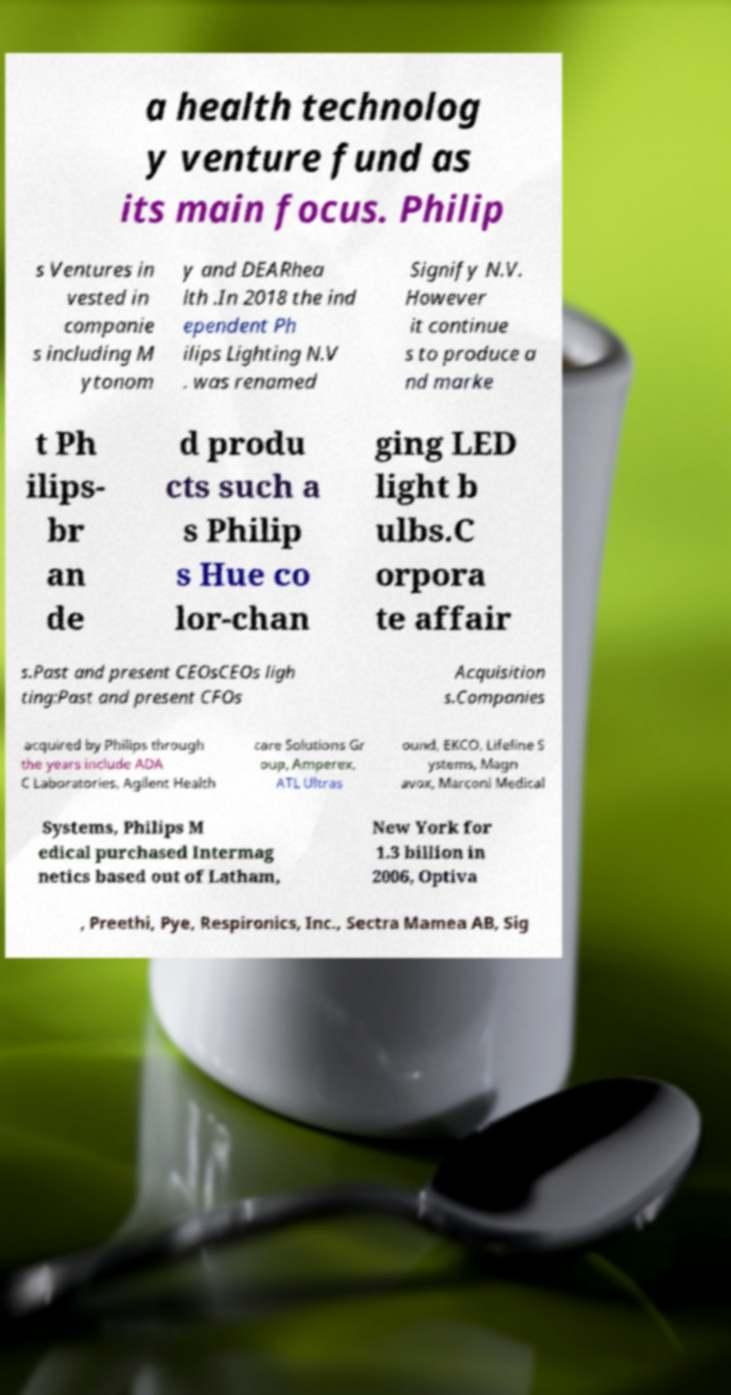Can you accurately transcribe the text from the provided image for me? a health technolog y venture fund as its main focus. Philip s Ventures in vested in companie s including M ytonom y and DEARhea lth .In 2018 the ind ependent Ph ilips Lighting N.V . was renamed Signify N.V. However it continue s to produce a nd marke t Ph ilips- br an de d produ cts such a s Philip s Hue co lor-chan ging LED light b ulbs.C orpora te affair s.Past and present CEOsCEOs ligh ting:Past and present CFOs Acquisition s.Companies acquired by Philips through the years include ADA C Laboratories, Agilent Health care Solutions Gr oup, Amperex, ATL Ultras ound, EKCO, Lifeline S ystems, Magn avox, Marconi Medical Systems, Philips M edical purchased Intermag netics based out of Latham, New York for 1.3 billion in 2006, Optiva , Preethi, Pye, Respironics, Inc., Sectra Mamea AB, Sig 